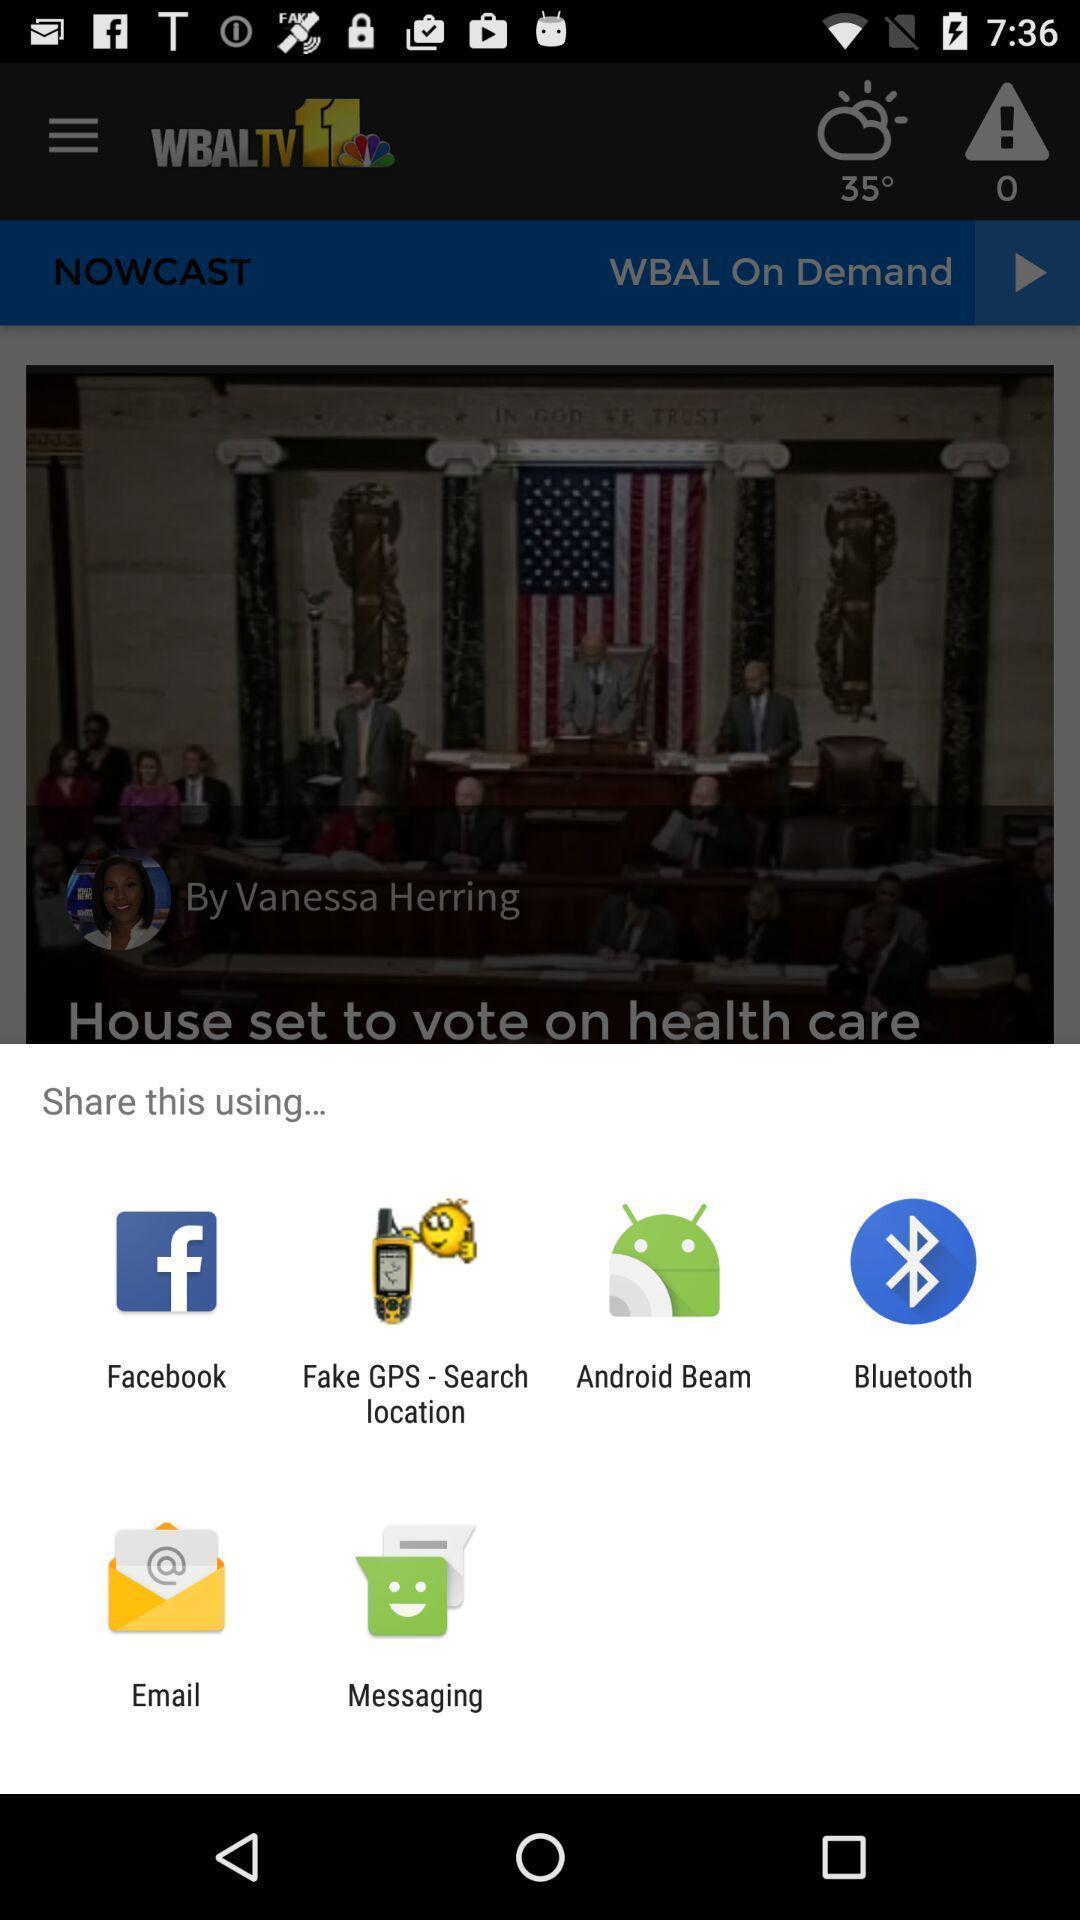Provide a textual representation of this image. Pop-up showing various share options. 